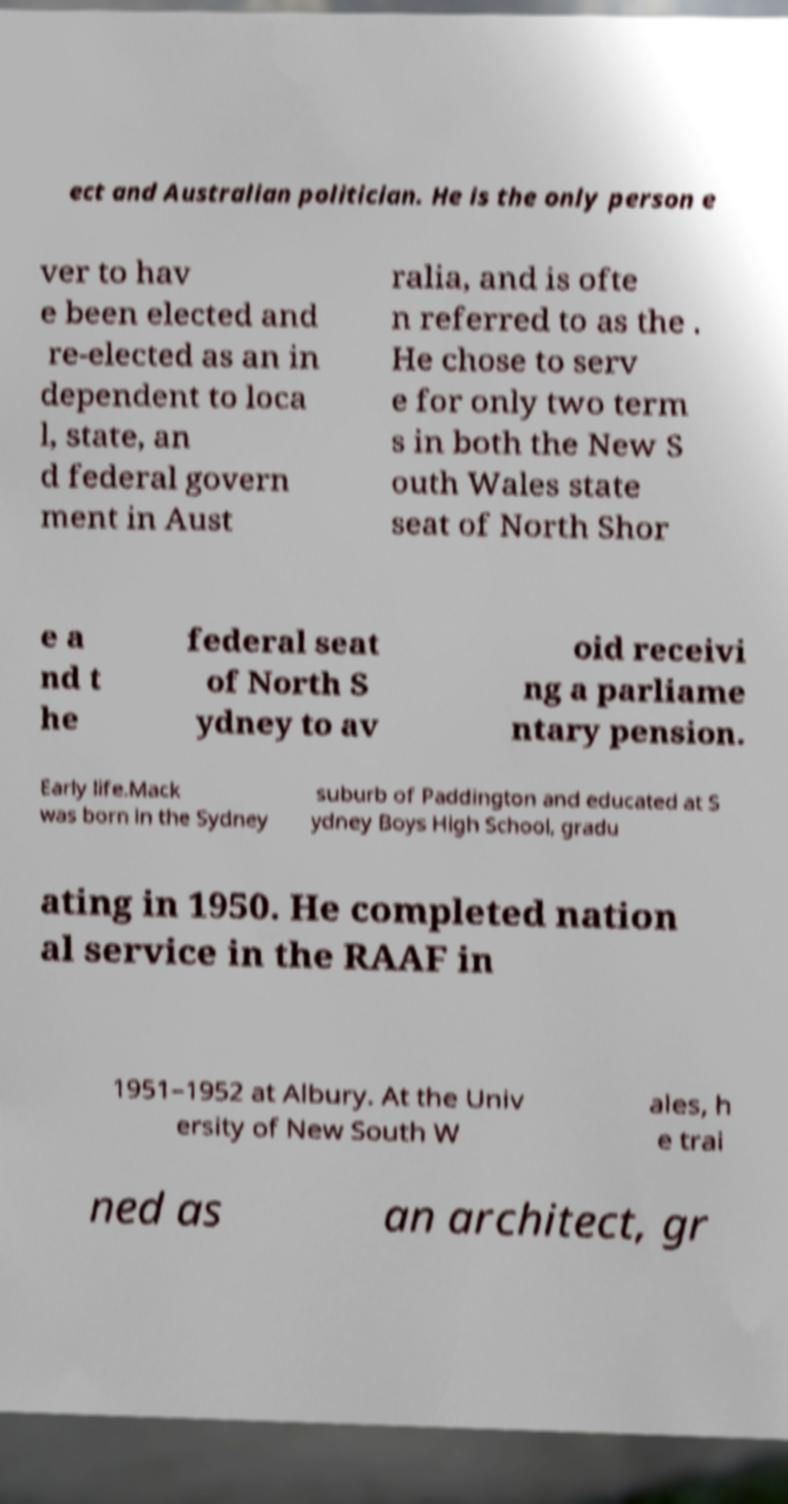Please read and relay the text visible in this image. What does it say? ect and Australian politician. He is the only person e ver to hav e been elected and re-elected as an in dependent to loca l, state, an d federal govern ment in Aust ralia, and is ofte n referred to as the . He chose to serv e for only two term s in both the New S outh Wales state seat of North Shor e a nd t he federal seat of North S ydney to av oid receivi ng a parliame ntary pension. Early life.Mack was born in the Sydney suburb of Paddington and educated at S ydney Boys High School, gradu ating in 1950. He completed nation al service in the RAAF in 1951–1952 at Albury. At the Univ ersity of New South W ales, h e trai ned as an architect, gr 